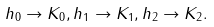<formula> <loc_0><loc_0><loc_500><loc_500>h _ { 0 } \to K _ { 0 } , h _ { 1 } \to K _ { 1 } , h _ { 2 } \to K _ { 2 } .</formula> 